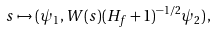Convert formula to latex. <formula><loc_0><loc_0><loc_500><loc_500>s \mapsto ( \psi _ { 1 } , W ( s ) ( H _ { f } + 1 ) ^ { - 1 / 2 } \psi _ { 2 } ) \, ,</formula> 